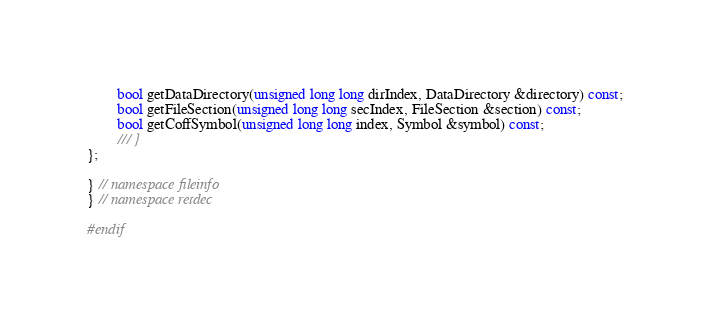Convert code to text. <code><loc_0><loc_0><loc_500><loc_500><_C_>		bool getDataDirectory(unsigned long long dirIndex, DataDirectory &directory) const;
		bool getFileSection(unsigned long long secIndex, FileSection &section) const;
		bool getCoffSymbol(unsigned long long index, Symbol &symbol) const;
		/// }
};

} // namespace fileinfo
} // namespace retdec

#endif
</code> 